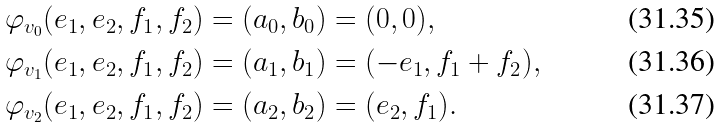<formula> <loc_0><loc_0><loc_500><loc_500>\varphi _ { v _ { 0 } } ( e _ { 1 } , e _ { 2 } , f _ { 1 } , f _ { 2 } ) & = ( a _ { 0 } , b _ { 0 } ) = ( 0 , 0 ) , \\ \varphi _ { v _ { 1 } } ( e _ { 1 } , e _ { 2 } , f _ { 1 } , f _ { 2 } ) & = ( a _ { 1 } , b _ { 1 } ) = ( - e _ { 1 } , f _ { 1 } + f _ { 2 } ) , \\ \varphi _ { v _ { 2 } } ( e _ { 1 } , e _ { 2 } , f _ { 1 } , f _ { 2 } ) & = ( a _ { 2 } , b _ { 2 } ) = ( e _ { 2 } , f _ { 1 } ) .</formula> 